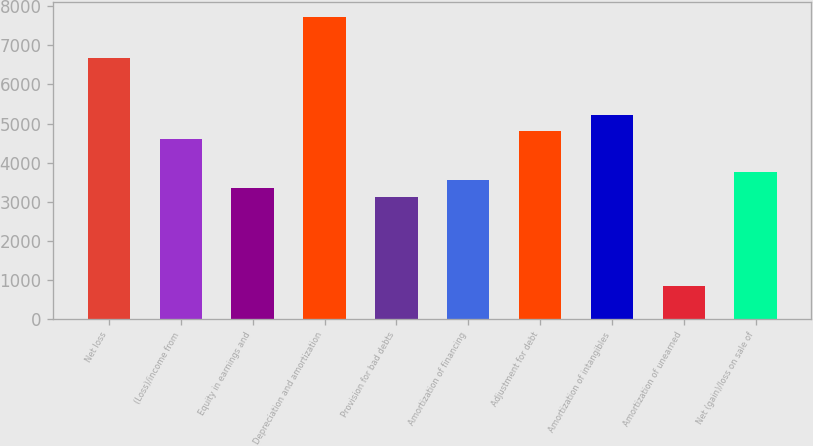Convert chart. <chart><loc_0><loc_0><loc_500><loc_500><bar_chart><fcel>Net loss<fcel>(Loss)/income from<fcel>Equity in earnings and<fcel>Depreciation and amortization<fcel>Provision for bad debts<fcel>Amortization of financing<fcel>Adjustment for debt<fcel>Amortization of intangibles<fcel>Amortization of unearned<fcel>Net (gain)/loss on sale of<nl><fcel>6679.4<fcel>4592.4<fcel>3340.2<fcel>7722.9<fcel>3131.5<fcel>3548.9<fcel>4801.1<fcel>5218.5<fcel>835.8<fcel>3757.6<nl></chart> 